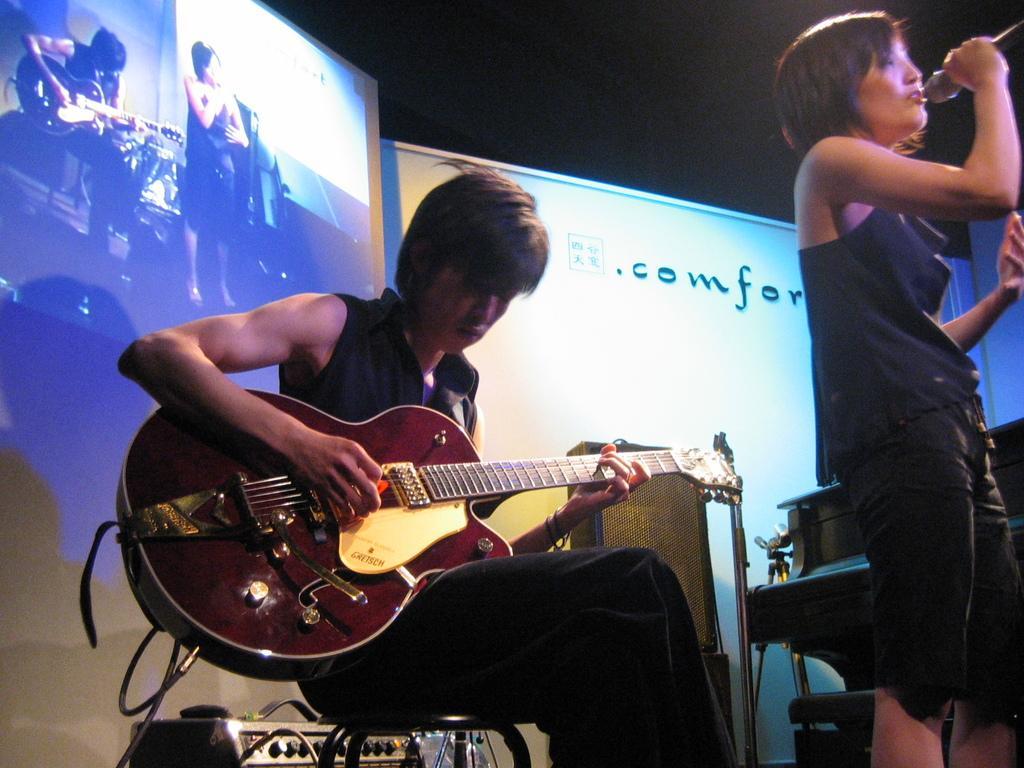Describe this image in one or two sentences. In this image we can see a person is sitting on a stool and playing guitar and on the right side we can see a person is standing and holding a mic in the hand. In the background there is a stand, electronic device, stand, objects, screen and text written on a board. 